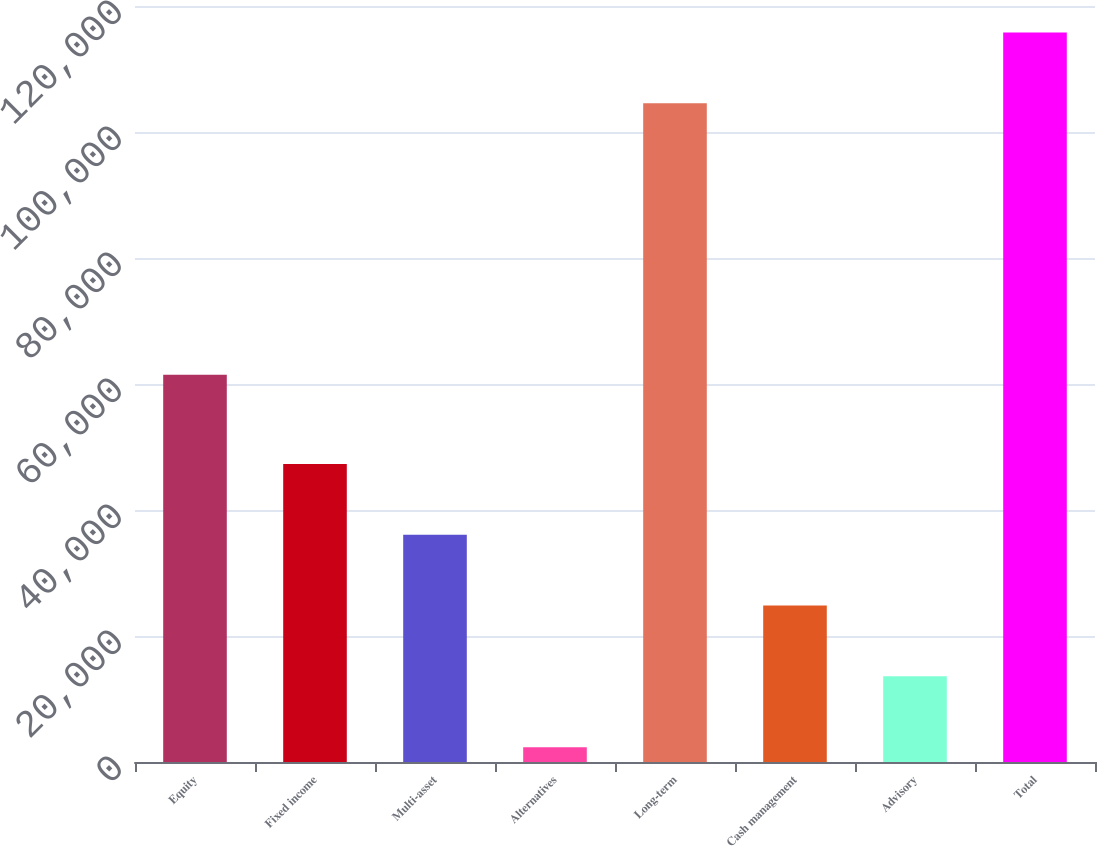<chart> <loc_0><loc_0><loc_500><loc_500><bar_chart><fcel>Equity<fcel>Fixed income<fcel>Multi-asset<fcel>Alternatives<fcel>Long-term<fcel>Cash management<fcel>Advisory<fcel>Total<nl><fcel>61478<fcel>47312<fcel>36073<fcel>2356<fcel>104563<fcel>24834<fcel>13595<fcel>115802<nl></chart> 